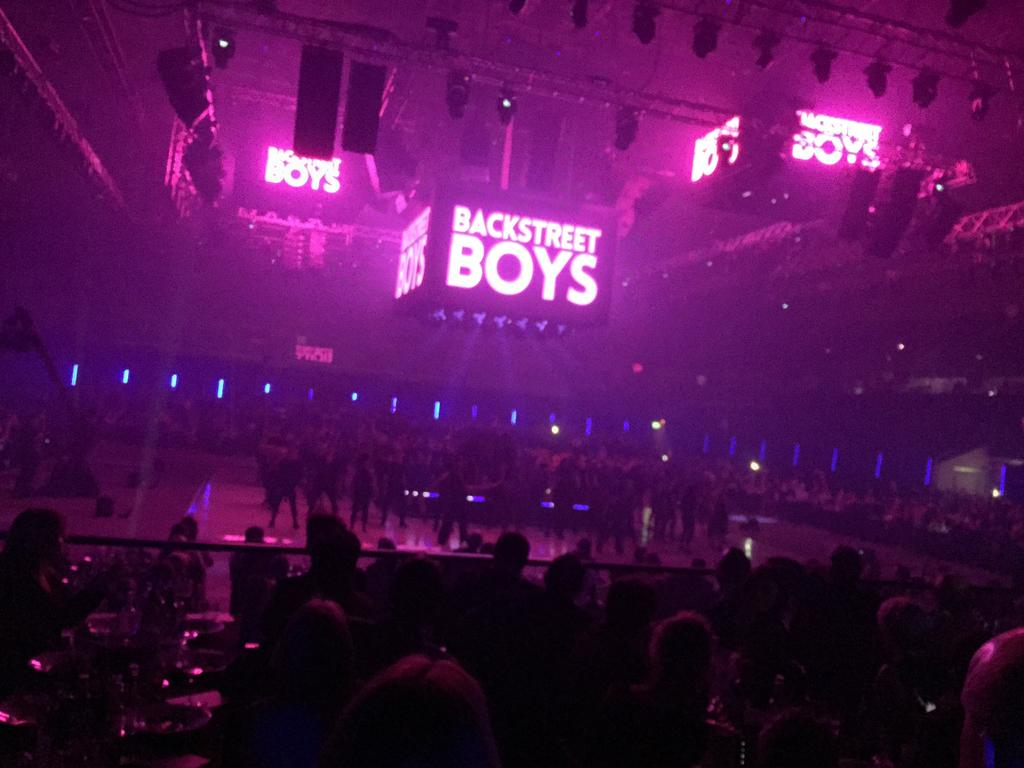Who or what can be seen in the image? There are people in the image. What is the background of the image? There is a wall in the image. What can be seen illuminating the scene? There are lights in the image. What is the main focus of the image? There is a stage in the image. What type of jewel is being kicked on the stage in the image? There is no jewel or kicking action present in the image. 